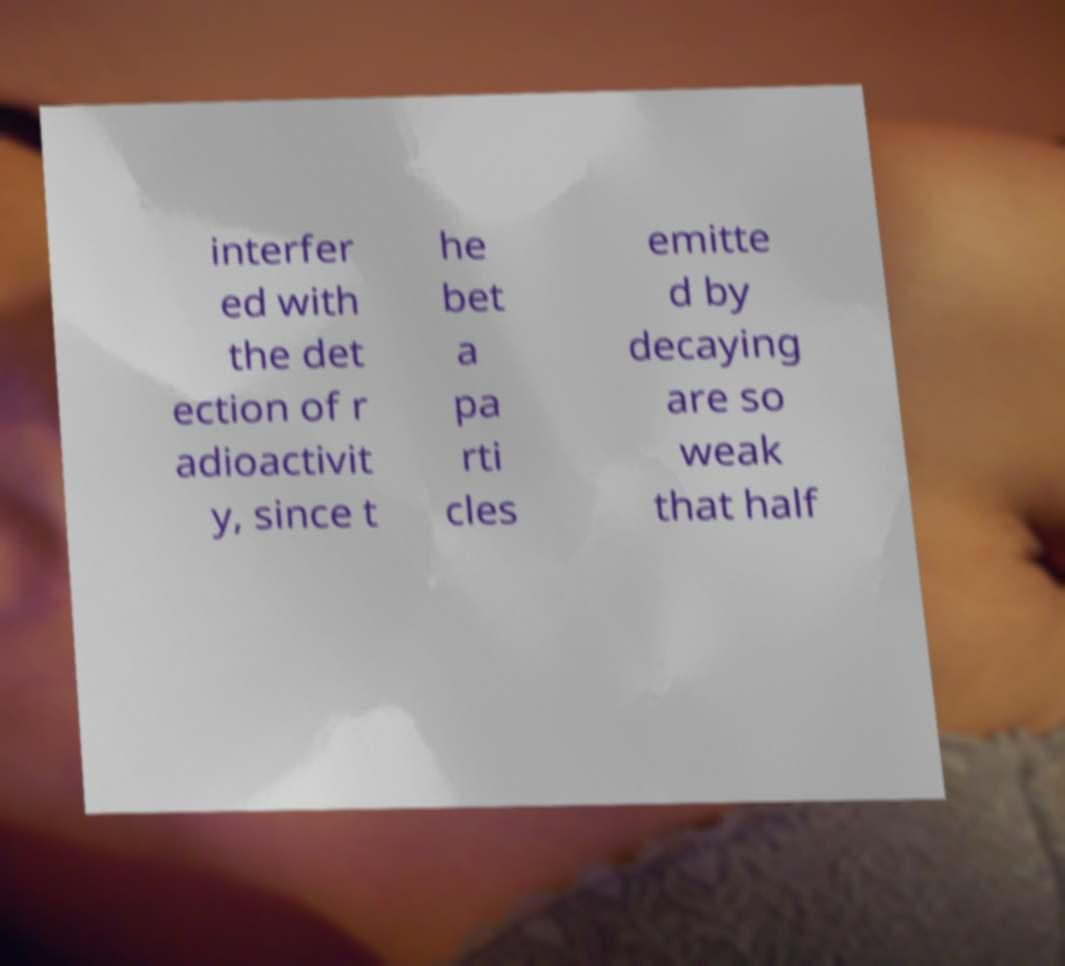Please identify and transcribe the text found in this image. interfer ed with the det ection of r adioactivit y, since t he bet a pa rti cles emitte d by decaying are so weak that half 